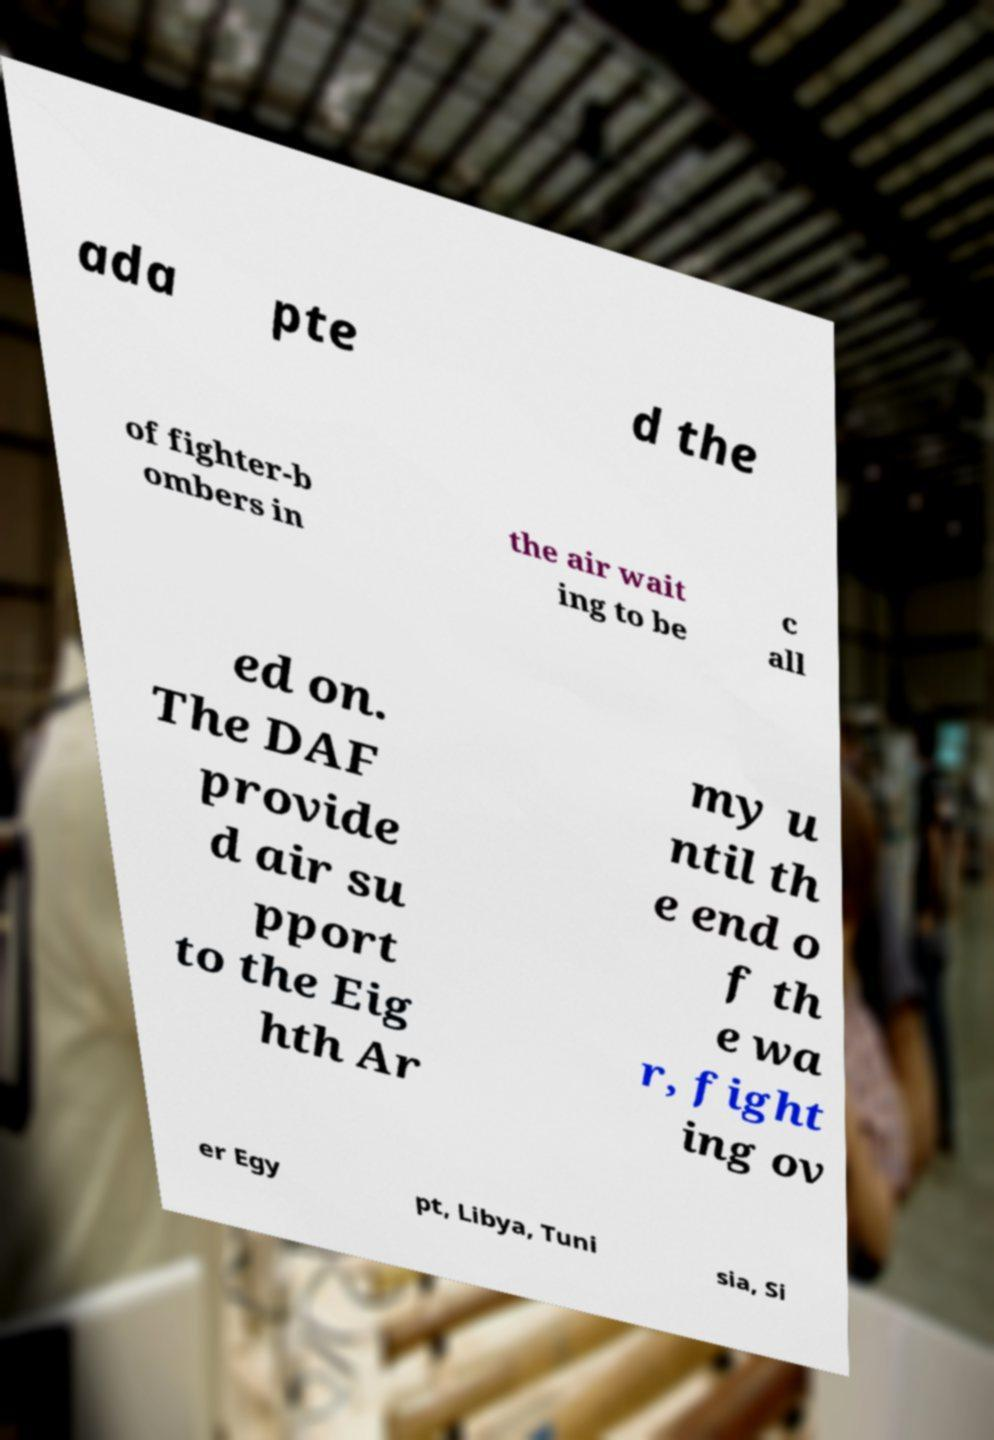Could you assist in decoding the text presented in this image and type it out clearly? ada pte d the of fighter-b ombers in the air wait ing to be c all ed on. The DAF provide d air su pport to the Eig hth Ar my u ntil th e end o f th e wa r, fight ing ov er Egy pt, Libya, Tuni sia, Si 